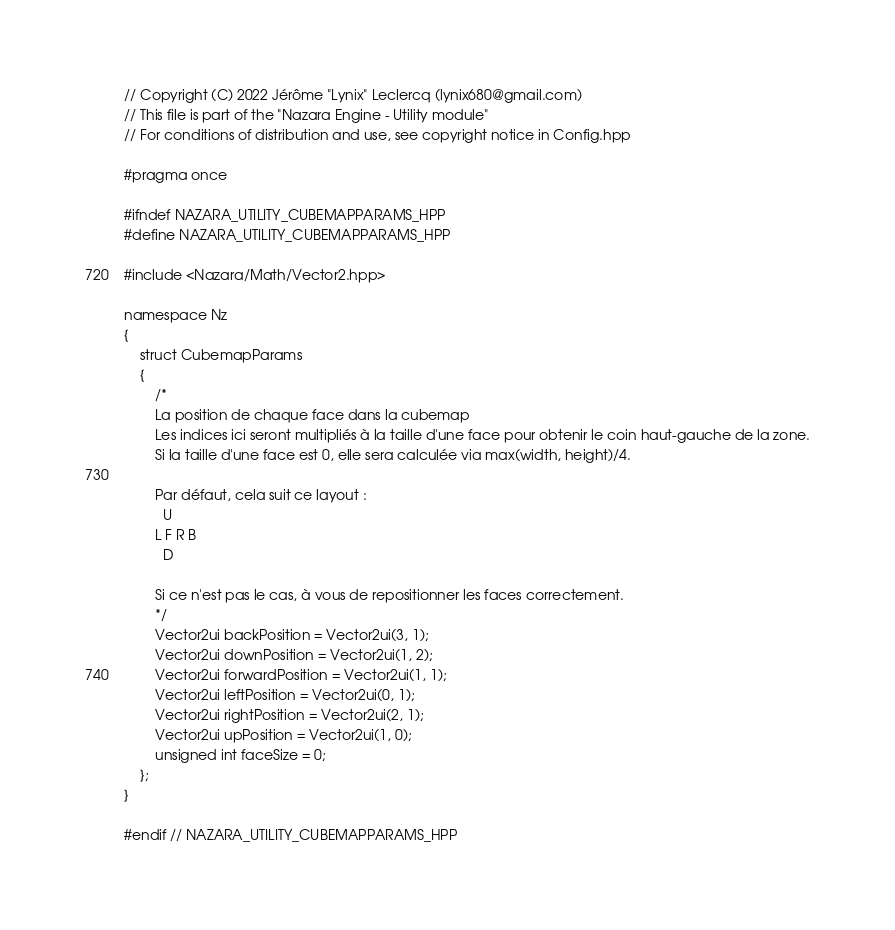Convert code to text. <code><loc_0><loc_0><loc_500><loc_500><_C++_>// Copyright (C) 2022 Jérôme "Lynix" Leclercq (lynix680@gmail.com)
// This file is part of the "Nazara Engine - Utility module"
// For conditions of distribution and use, see copyright notice in Config.hpp

#pragma once

#ifndef NAZARA_UTILITY_CUBEMAPPARAMS_HPP
#define NAZARA_UTILITY_CUBEMAPPARAMS_HPP

#include <Nazara/Math/Vector2.hpp>

namespace Nz
{
	struct CubemapParams
	{
		/*
		La position de chaque face dans la cubemap
		Les indices ici seront multipliés à la taille d'une face pour obtenir le coin haut-gauche de la zone.
		Si la taille d'une face est 0, elle sera calculée via max(width, height)/4.

		Par défaut, cela suit ce layout :
		  U
		L F R B
		  D

		Si ce n'est pas le cas, à vous de repositionner les faces correctement.
		*/
		Vector2ui backPosition = Vector2ui(3, 1);
		Vector2ui downPosition = Vector2ui(1, 2);
		Vector2ui forwardPosition = Vector2ui(1, 1);
		Vector2ui leftPosition = Vector2ui(0, 1);
		Vector2ui rightPosition = Vector2ui(2, 1);
		Vector2ui upPosition = Vector2ui(1, 0);
		unsigned int faceSize = 0;
	};
}

#endif // NAZARA_UTILITY_CUBEMAPPARAMS_HPP
</code> 